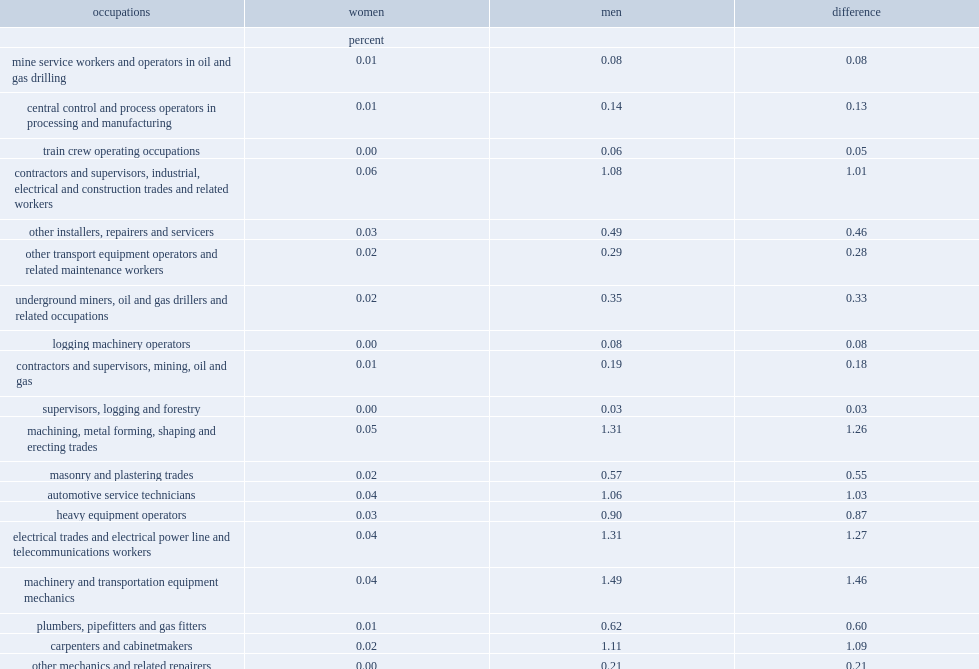What is the percentage of men who were in the total 20 occupations men in 2017? 11.52. 